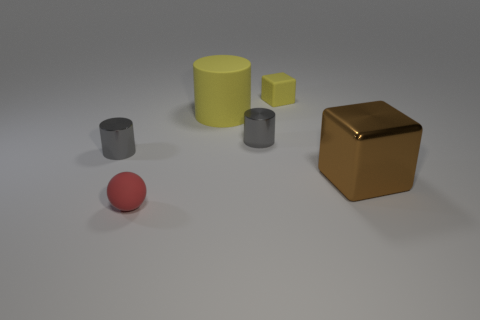Add 1 tiny gray things. How many objects exist? 7 Subtract all spheres. How many objects are left? 5 Subtract all tiny yellow cubes. Subtract all big matte objects. How many objects are left? 4 Add 5 large yellow cylinders. How many large yellow cylinders are left? 6 Add 1 red rubber spheres. How many red rubber spheres exist? 2 Subtract 0 brown cylinders. How many objects are left? 6 